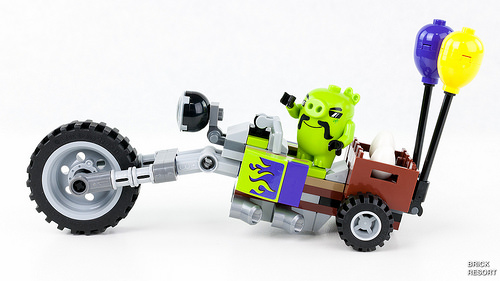<image>
Can you confirm if the evil pig is on the motorcycle? Yes. Looking at the image, I can see the evil pig is positioned on top of the motorcycle, with the motorcycle providing support. Is there a flames behind the vehicle? No. The flames is not behind the vehicle. From this viewpoint, the flames appears to be positioned elsewhere in the scene. 